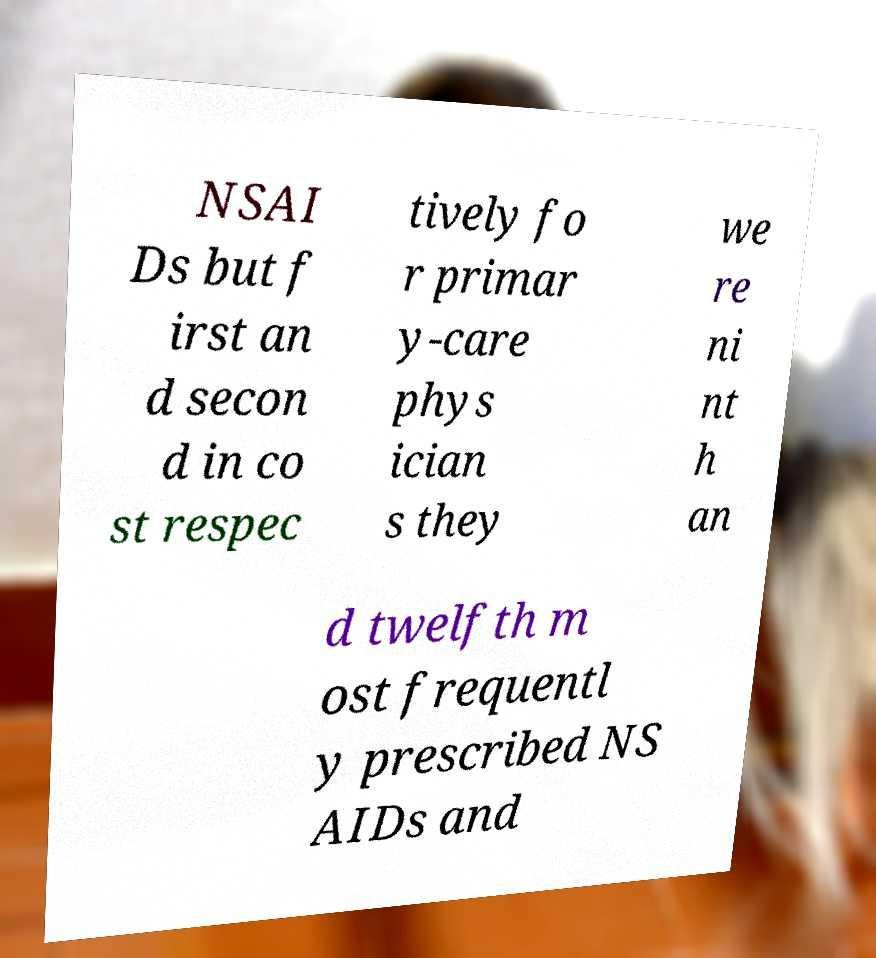Could you assist in decoding the text presented in this image and type it out clearly? NSAI Ds but f irst an d secon d in co st respec tively fo r primar y-care phys ician s they we re ni nt h an d twelfth m ost frequentl y prescribed NS AIDs and 